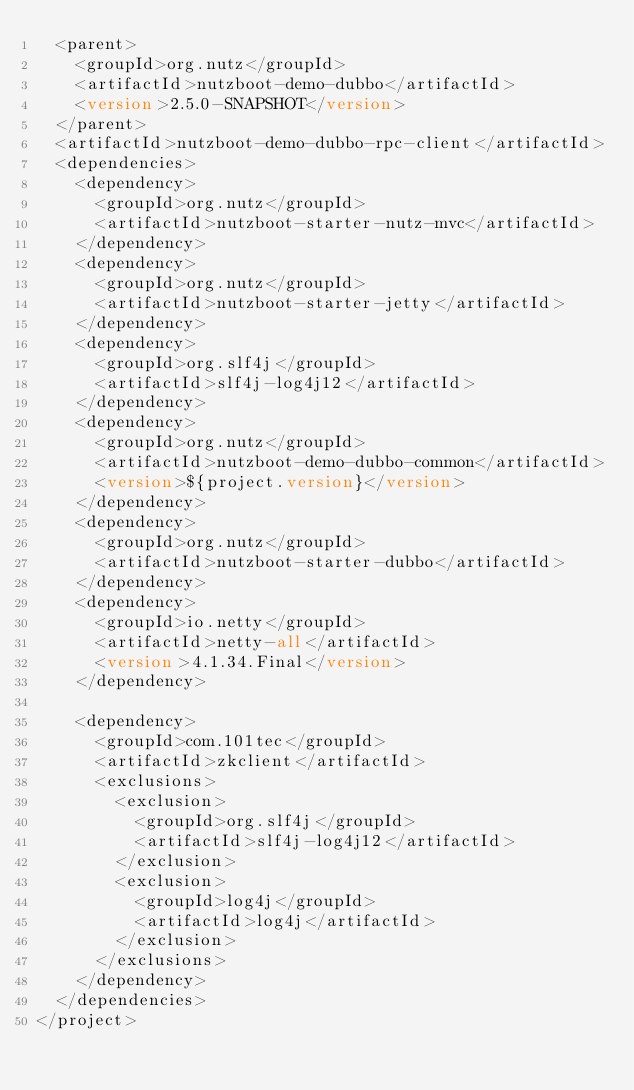<code> <loc_0><loc_0><loc_500><loc_500><_XML_>	<parent>
		<groupId>org.nutz</groupId>
		<artifactId>nutzboot-demo-dubbo</artifactId>
		<version>2.5.0-SNAPSHOT</version>
	</parent>
	<artifactId>nutzboot-demo-dubbo-rpc-client</artifactId>
	<dependencies>
		<dependency>
			<groupId>org.nutz</groupId>
			<artifactId>nutzboot-starter-nutz-mvc</artifactId>
		</dependency>
		<dependency>
			<groupId>org.nutz</groupId>
			<artifactId>nutzboot-starter-jetty</artifactId>
		</dependency>
		<dependency>
			<groupId>org.slf4j</groupId>
			<artifactId>slf4j-log4j12</artifactId>
		</dependency>
		<dependency>
			<groupId>org.nutz</groupId>
			<artifactId>nutzboot-demo-dubbo-common</artifactId>
			<version>${project.version}</version>
		</dependency>
		<dependency>
			<groupId>org.nutz</groupId>
			<artifactId>nutzboot-starter-dubbo</artifactId>
		</dependency>
		<dependency>
			<groupId>io.netty</groupId>
			<artifactId>netty-all</artifactId>
			<version>4.1.34.Final</version>
		</dependency>
		
		<dependency>
			<groupId>com.101tec</groupId>
			<artifactId>zkclient</artifactId>
			<exclusions>
				<exclusion>
					<groupId>org.slf4j</groupId>
					<artifactId>slf4j-log4j12</artifactId>
				</exclusion>
				<exclusion>
					<groupId>log4j</groupId>
					<artifactId>log4j</artifactId>
				</exclusion>
			</exclusions>
		</dependency>
	</dependencies>
</project></code> 